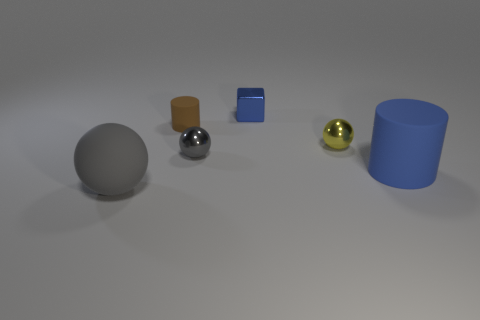Add 4 large matte cylinders. How many objects exist? 10 Subtract all blocks. How many objects are left? 5 Add 5 cubes. How many cubes exist? 6 Subtract 0 purple cylinders. How many objects are left? 6 Subtract all small metallic things. Subtract all metallic spheres. How many objects are left? 1 Add 6 gray shiny objects. How many gray shiny objects are left? 7 